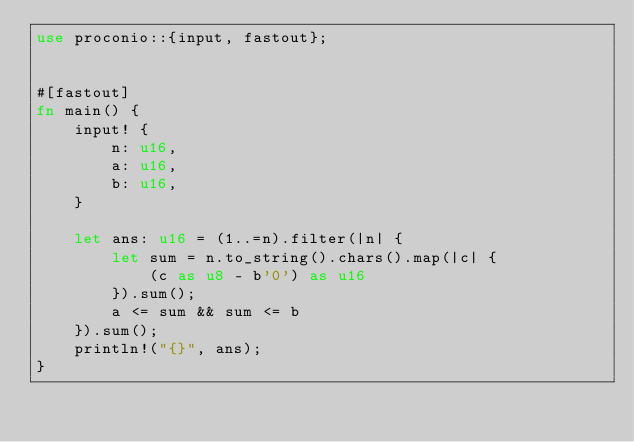<code> <loc_0><loc_0><loc_500><loc_500><_Rust_>use proconio::{input, fastout};


#[fastout]
fn main() {
    input! {
        n: u16,
        a: u16,
        b: u16,
    }

    let ans: u16 = (1..=n).filter(|n| {
        let sum = n.to_string().chars().map(|c| {
            (c as u8 - b'0') as u16
        }).sum();
        a <= sum && sum <= b
    }).sum();
    println!("{}", ans);
}
</code> 